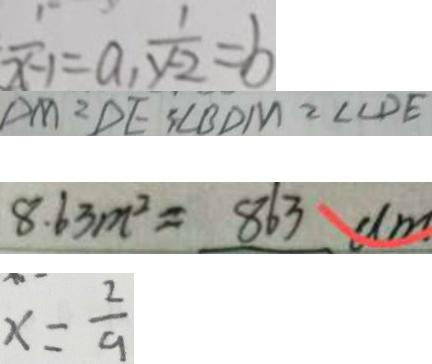<formula> <loc_0><loc_0><loc_500><loc_500>\frac { 1 } { x - 1 } = a , \frac { 1 } { y - 2 } = b 
 D M = D E 3 \angle B D M = \angle C D E 
 8 . 6 3 m ^ { 2 } = 8 6 3 d m 
 x = \frac { 2 } { 9 }</formula> 